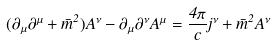<formula> <loc_0><loc_0><loc_500><loc_500>( \partial _ { \mu } \partial ^ { \mu } + \bar { m } ^ { 2 } ) A ^ { \nu } - \partial _ { \mu } \partial ^ { \nu } A ^ { \mu } = \frac { 4 \pi } { c } j ^ { \nu } + \bar { m } ^ { 2 } A ^ { \nu }</formula> 